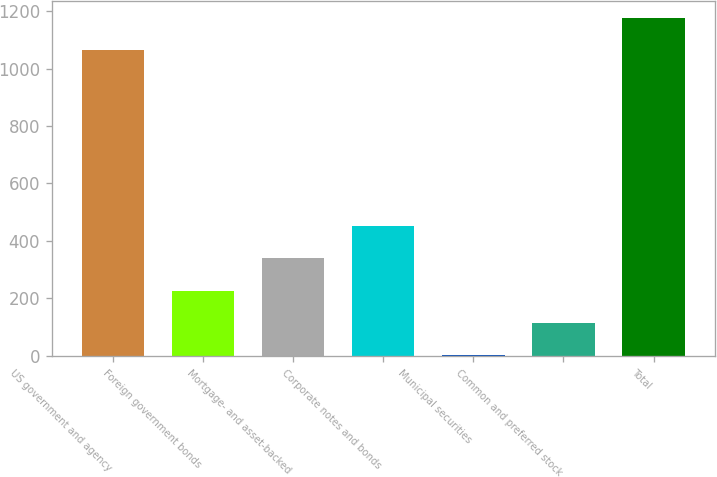Convert chart to OTSL. <chart><loc_0><loc_0><loc_500><loc_500><bar_chart><fcel>US government and agency<fcel>Foreign government bonds<fcel>Mortgage- and asset-backed<fcel>Corporate notes and bonds<fcel>Municipal securities<fcel>Common and preferred stock<fcel>Total<nl><fcel>1064<fcel>226.8<fcel>339.7<fcel>452.6<fcel>1<fcel>113.9<fcel>1176.9<nl></chart> 